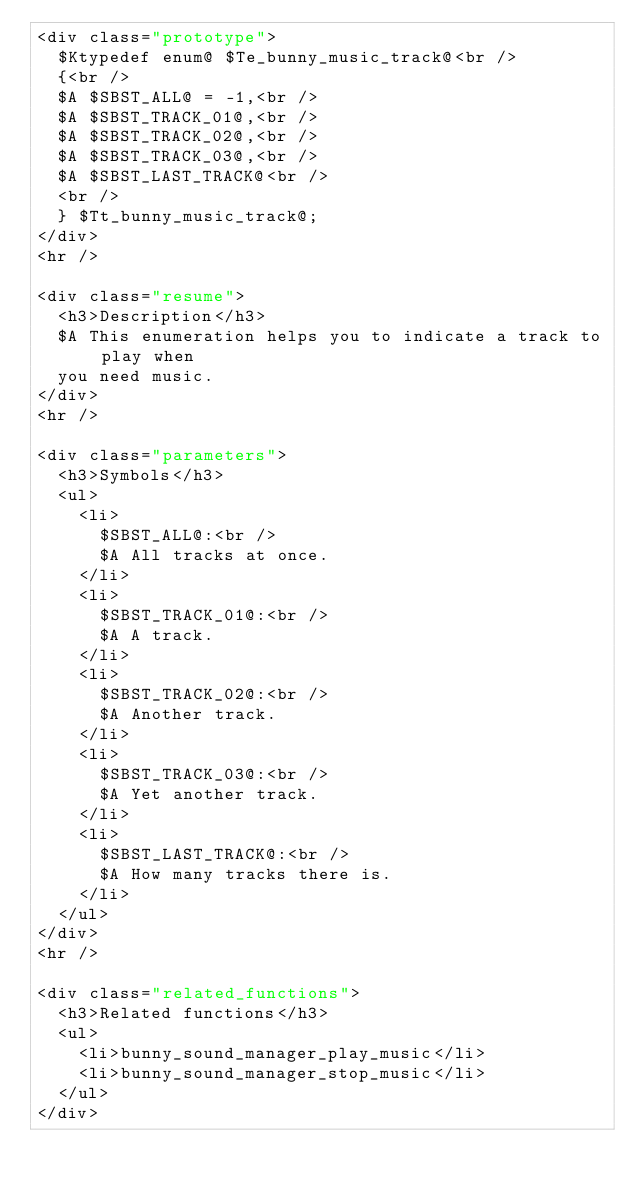Convert code to text. <code><loc_0><loc_0><loc_500><loc_500><_PHP_><div class="prototype">
  $Ktypedef enum@ $Te_bunny_music_track@<br />
  {<br />
  $A $SBST_ALL@ = -1,<br />
  $A $SBST_TRACK_01@,<br />
  $A $SBST_TRACK_02@,<br />
  $A $SBST_TRACK_03@,<br />
  $A $SBST_LAST_TRACK@<br />
  <br />
  } $Tt_bunny_music_track@;
</div>
<hr />

<div class="resume">
  <h3>Description</h3>
  $A This enumeration helps you to indicate a track to play when
  you need music.
</div>
<hr />

<div class="parameters">
  <h3>Symbols</h3>
  <ul>
    <li>
      $SBST_ALL@:<br />
      $A All tracks at once.
    </li>
    <li>
      $SBST_TRACK_01@:<br />
      $A A track.
    </li>
    <li>
      $SBST_TRACK_02@:<br />
      $A Another track.
    </li>
    <li>
      $SBST_TRACK_03@:<br />
      $A Yet another track.
    </li>
    <li>
      $SBST_LAST_TRACK@:<br />
      $A How many tracks there is.
    </li>
  </ul>
</div>
<hr />

<div class="related_functions">
  <h3>Related functions</h3>
  <ul>
    <li>bunny_sound_manager_play_music</li>
    <li>bunny_sound_manager_stop_music</li>
  </ul>
</div>

</code> 